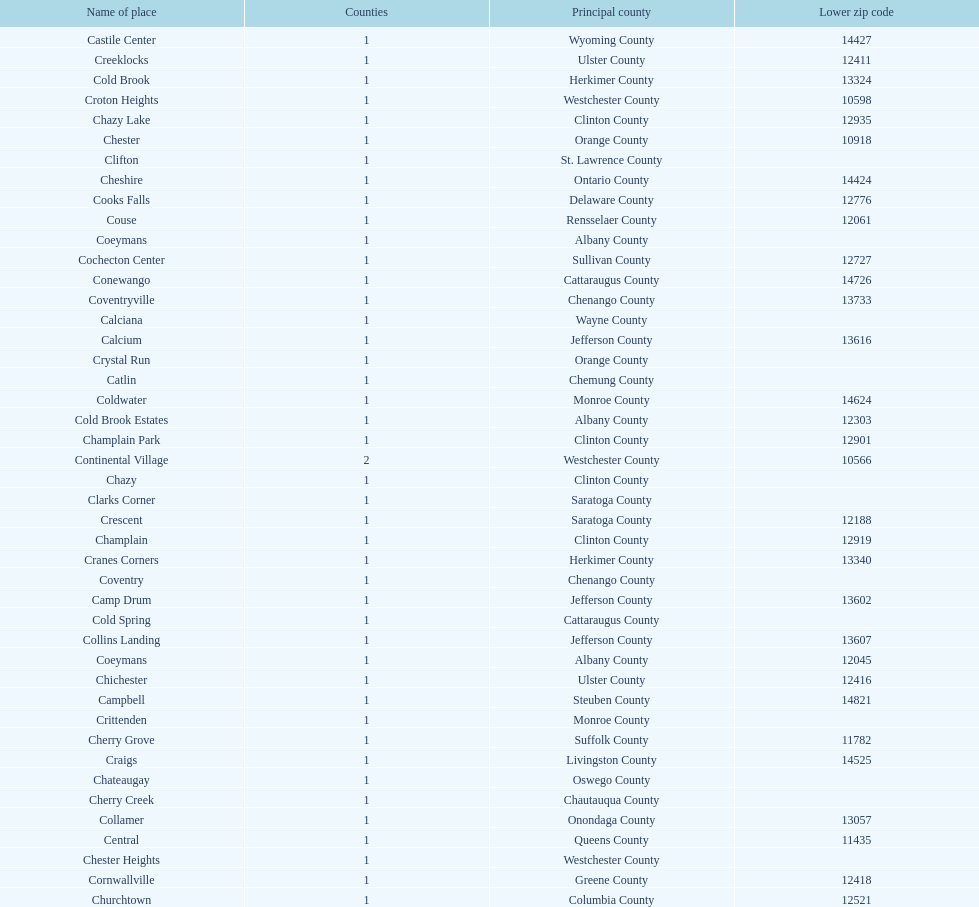How many places are in greene county? 10. 